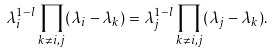Convert formula to latex. <formula><loc_0><loc_0><loc_500><loc_500>\lambda _ { i } ^ { 1 - l } \prod _ { k \ne i , j } ( \lambda _ { i } - \lambda _ { k } ) = \lambda _ { j } ^ { 1 - l } \prod _ { k \ne i , j } ( \lambda _ { j } - \lambda _ { k } ) .</formula> 